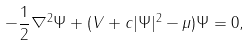<formula> <loc_0><loc_0><loc_500><loc_500>- \frac { 1 } { 2 } \nabla ^ { 2 } \Psi + ( V + c | \Psi | ^ { 2 } - \mu ) \Psi & = 0 ,</formula> 